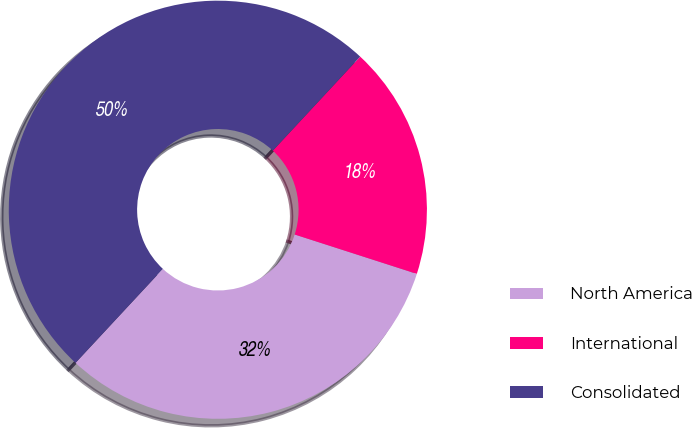Convert chart. <chart><loc_0><loc_0><loc_500><loc_500><pie_chart><fcel>North America<fcel>International<fcel>Consolidated<nl><fcel>31.96%<fcel>18.04%<fcel>50.0%<nl></chart> 